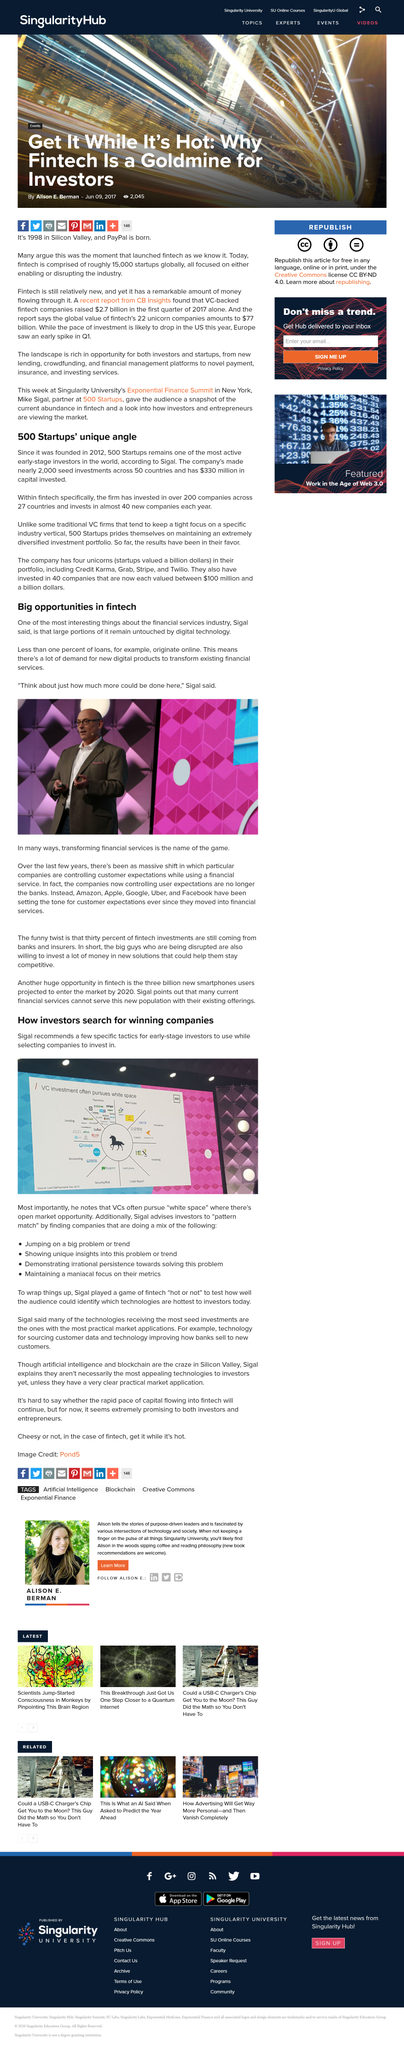Point out several critical features in this image. The financial services industry is referred to in this article. According to Sigal, less than one percent of loans originate online. Sigal wrapped up the game with Fintech "hot or not. 500 Startups, a company founded in 2012, has been providing valuable resources and support to entrepreneurs and startups for over seven years. At 500 Startups, we take pride in maintaining a diversified investment portfolio that reflects our commitment to inclusivity and representation in the tech industry. 